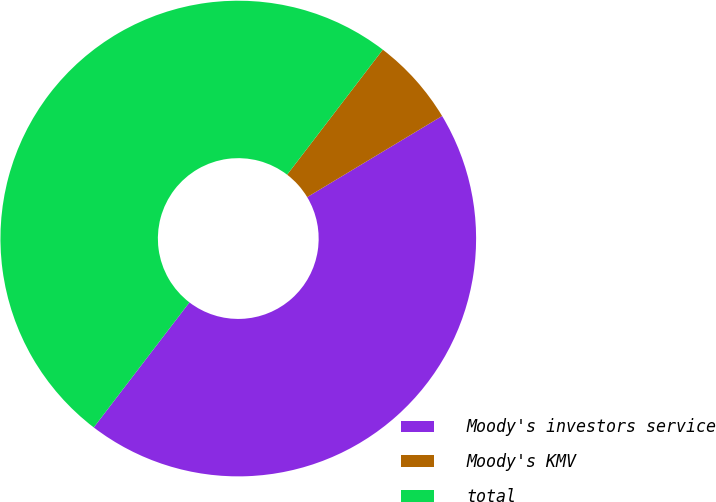Convert chart to OTSL. <chart><loc_0><loc_0><loc_500><loc_500><pie_chart><fcel>Moody's investors service<fcel>Moody's KMV<fcel>total<nl><fcel>44.01%<fcel>5.99%<fcel>50.0%<nl></chart> 